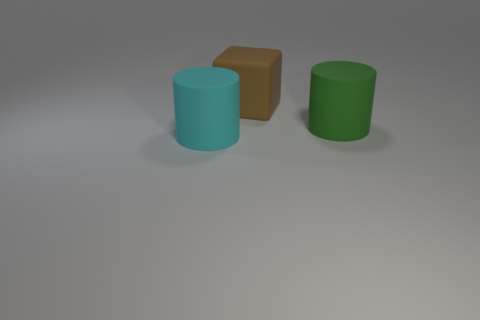What number of large matte blocks are behind the rubber cylinder that is right of the big cylinder in front of the large green object?
Your response must be concise. 1. What size is the other rubber thing that is the same shape as the big green matte thing?
Your answer should be compact. Large. What is the color of the other large matte thing that is the same shape as the large green thing?
Keep it short and to the point. Cyan. There is a large matte thing that is in front of the large green rubber object; is it the same shape as the green matte thing on the right side of the brown matte block?
Ensure brevity in your answer.  Yes. How many cylinders are either large brown things or cyan things?
Offer a very short reply. 1. Are there fewer large brown things to the right of the green rubber thing than small green shiny spheres?
Make the answer very short. No. Do the cyan thing and the block have the same size?
Provide a short and direct response. Yes. How many things are objects behind the big cyan object or big cyan cylinders?
Provide a succinct answer. 3. What material is the big object behind the large object that is to the right of the brown cube made of?
Ensure brevity in your answer.  Rubber. Are there any other large things that have the same shape as the large cyan object?
Make the answer very short. Yes. 